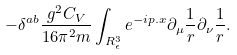<formula> <loc_0><loc_0><loc_500><loc_500>- \delta ^ { a b } \frac { g ^ { 2 } C _ { V } } { 1 6 \pi ^ { 2 } m } \int _ { R _ { \epsilon } ^ { 3 } } e ^ { - i p . x } \partial _ { \mu } \frac { 1 } { r } \partial _ { \nu } \frac { 1 } { r } .</formula> 